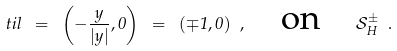<formula> <loc_0><loc_0><loc_500><loc_500>\ t i l \ = \ \left ( - \frac { y } { | y | } , 0 \right ) \ = \ ( \mp 1 , 0 ) \ , \quad \text {on} \quad \mathcal { S } _ { H } ^ { \pm } \ .</formula> 